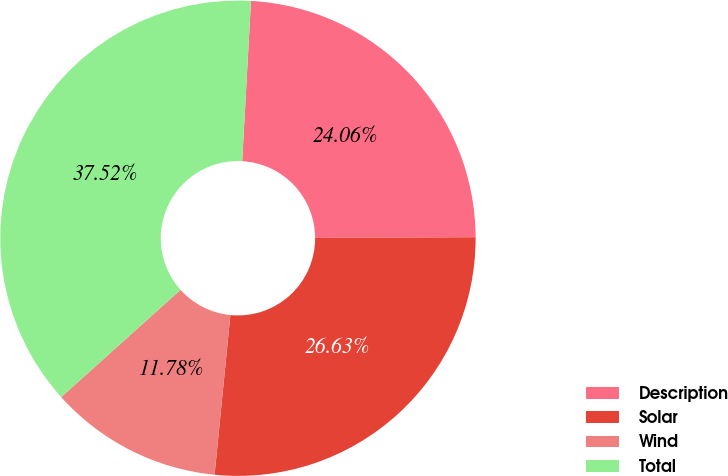Convert chart. <chart><loc_0><loc_0><loc_500><loc_500><pie_chart><fcel>Description<fcel>Solar<fcel>Wind<fcel>Total<nl><fcel>24.06%<fcel>26.63%<fcel>11.78%<fcel>37.52%<nl></chart> 